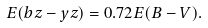Convert formula to latex. <formula><loc_0><loc_0><loc_500><loc_500>E ( b z - y z ) = 0 . 7 2 E ( B - V ) .</formula> 